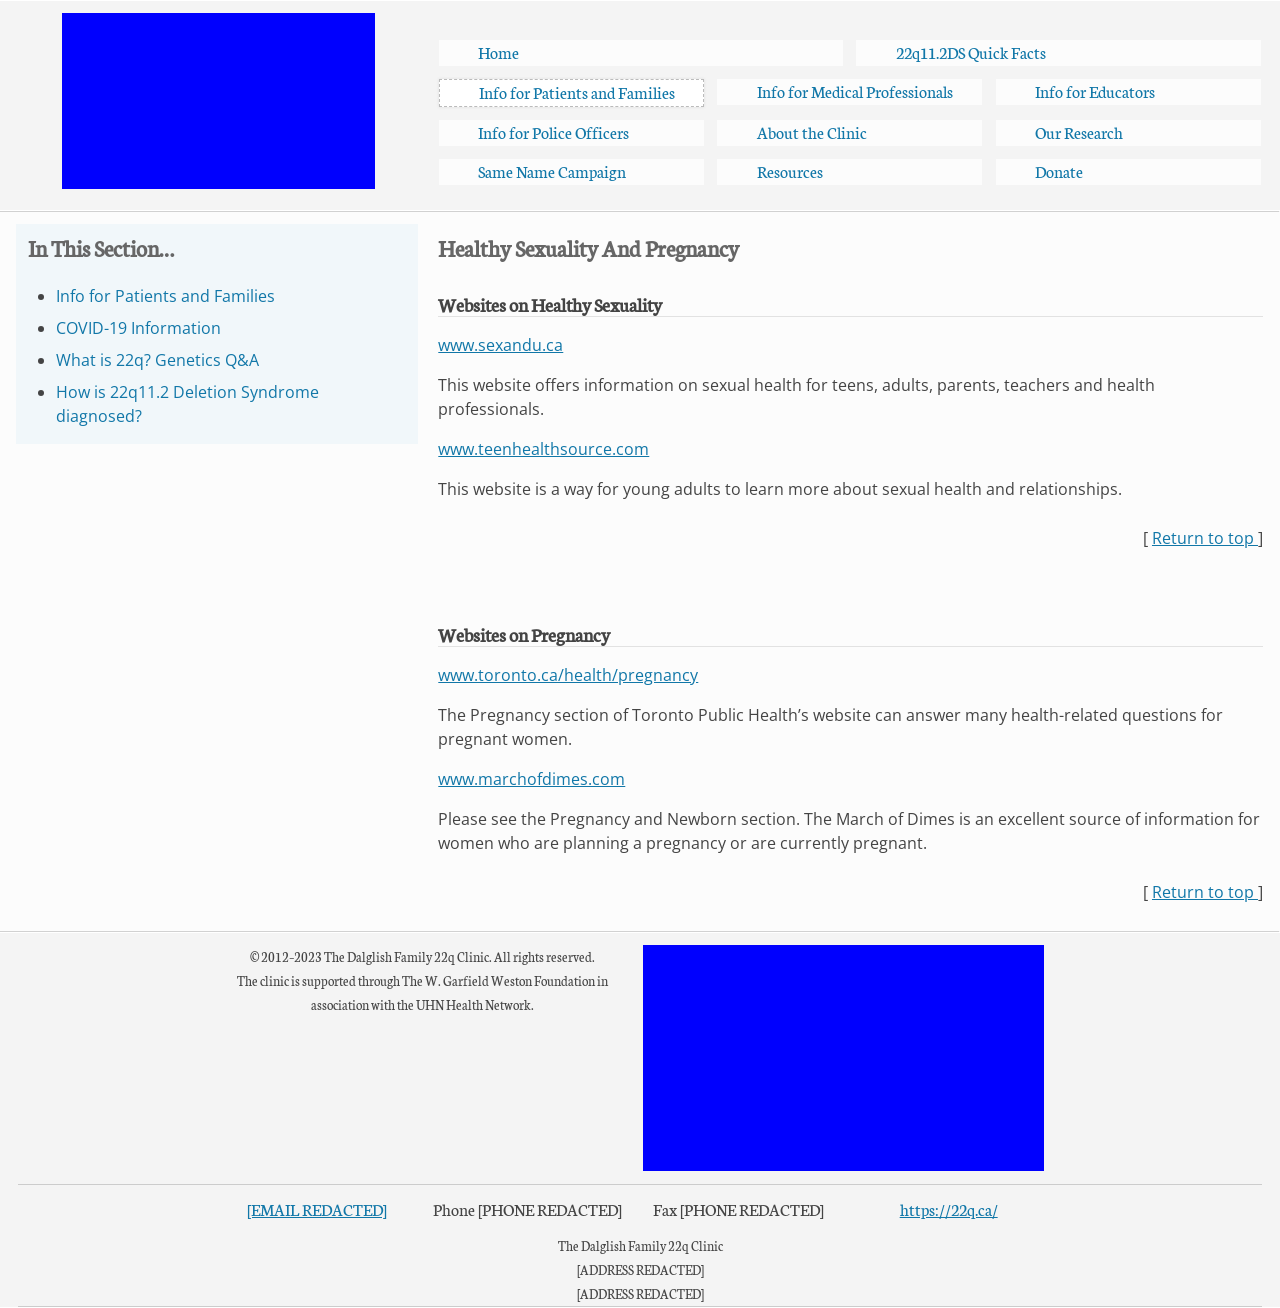What's the procedure for constructing this website from scratch with HTML? To construct a website similar to the one shown from scratch using HTML, you would begin by defining the DOCTYPE and the primary HTML structure. The 'head' section includes meta tags for character set and viewport settings, links to CSS for styles, and possibly JavaScript files for behavior. The 'body' contains the content structured into header, main, aside, and footer areas, using divs with class attribute for layout - responsive design can be achieved using media queries in CSS. The given HTML structure in the response is comprehensive, including various accessibility and structural elements, making it a robust base for custom content and further development. 